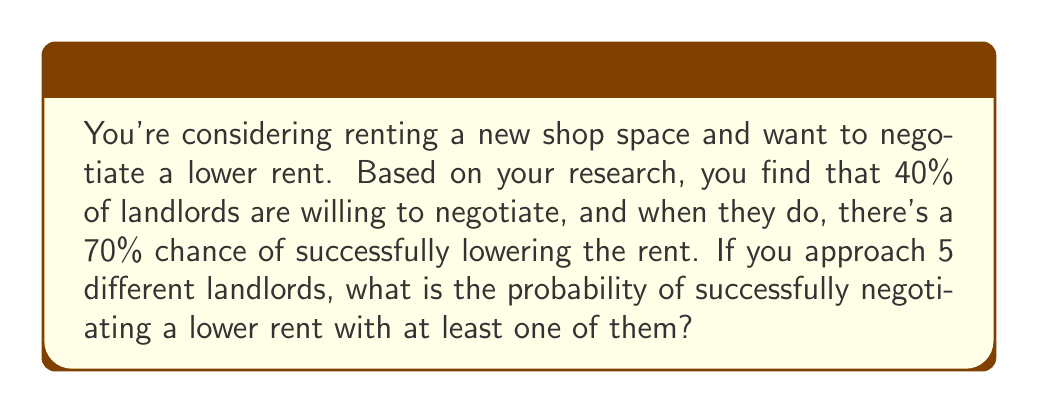What is the answer to this math problem? Let's approach this step-by-step:

1) First, let's calculate the probability of successfully negotiating with a single landlord:
   $P(\text{success with one landlord}) = P(\text{willing to negotiate}) \times P(\text{successful negotiation})$
   $= 0.40 \times 0.70 = 0.28$

2) Now, let's calculate the probability of failing to negotiate with a single landlord:
   $P(\text{failure with one landlord}) = 1 - P(\text{success with one landlord}) = 1 - 0.28 = 0.72$

3) For success with at least one landlord out of 5, we can calculate the complement of failing with all 5:
   $P(\text{success with at least one}) = 1 - P(\text{failure with all 5})$

4) The probability of failing with all 5 landlords is:
   $P(\text{failure with all 5}) = 0.72^5$

5) Therefore, the probability of success with at least one landlord is:
   $P(\text{success with at least one}) = 1 - 0.72^5$

6) Let's calculate this:
   $1 - 0.72^5 = 1 - 0.1889 = 0.8111$

7) Converting to a percentage:
   $0.8111 \times 100\% = 81.11\%$
Answer: 81.11% 